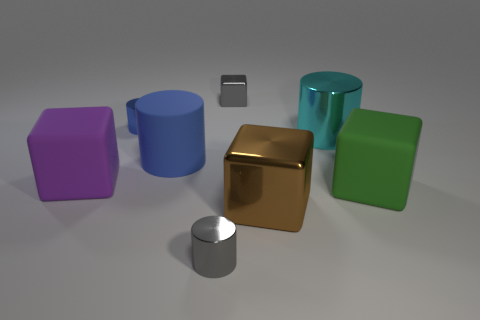Are there any other things that have the same color as the big metal cylinder?
Provide a short and direct response. No. There is a small shiny cylinder left of the small cylinder in front of the green matte object; is there a metallic thing that is in front of it?
Give a very brief answer. Yes. The big matte cylinder has what color?
Offer a very short reply. Blue. There is a large brown shiny object; are there any big green things to the left of it?
Offer a terse response. No. Is the shape of the green rubber thing the same as the large thing to the left of the big blue matte object?
Your answer should be very brief. Yes. What number of other things are there of the same material as the tiny gray cylinder
Ensure brevity in your answer.  4. What color is the tiny metallic block that is behind the cube left of the small gray shiny thing left of the small gray block?
Keep it short and to the point. Gray. What is the shape of the tiny gray object that is in front of the large matte block left of the big cyan metal object?
Provide a short and direct response. Cylinder. Is the number of cubes behind the big brown thing greater than the number of brown matte cylinders?
Offer a very short reply. Yes. There is a small thing in front of the large blue rubber thing; does it have the same shape as the cyan object?
Give a very brief answer. Yes. 